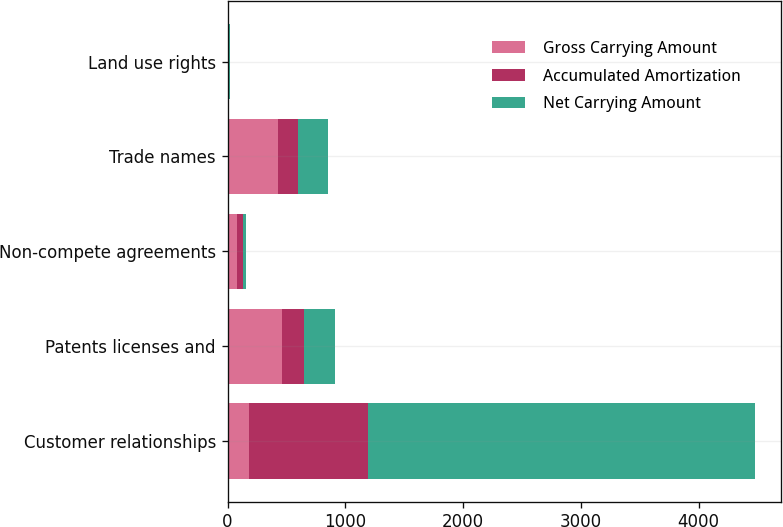<chart> <loc_0><loc_0><loc_500><loc_500><stacked_bar_chart><ecel><fcel>Customer relationships<fcel>Patents licenses and<fcel>Non-compete agreements<fcel>Trade names<fcel>Land use rights<nl><fcel>Gross Carrying Amount<fcel>180<fcel>457.9<fcel>79<fcel>426.3<fcel>10.9<nl><fcel>Accumulated Amortization<fcel>1014.9<fcel>188.6<fcel>49.4<fcel>171.4<fcel>2.6<nl><fcel>Net Carrying Amount<fcel>3283<fcel>269.3<fcel>29.6<fcel>254.9<fcel>8.3<nl></chart> 